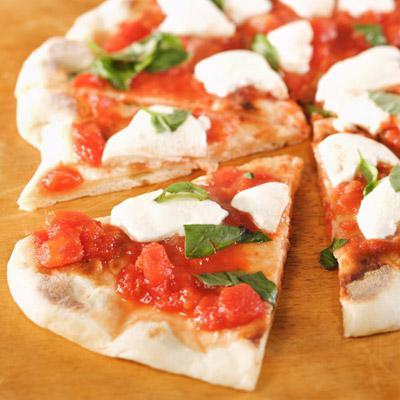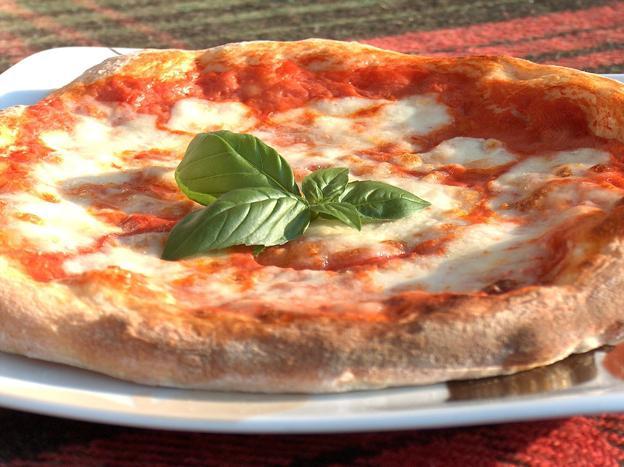The first image is the image on the left, the second image is the image on the right. Examine the images to the left and right. Is the description "There are two circle pizzas each on a plate or pan." accurate? Answer yes or no. No. The first image is the image on the left, the second image is the image on the right. For the images shown, is this caption "There is an uncut pizza in the right image." true? Answer yes or no. Yes. 